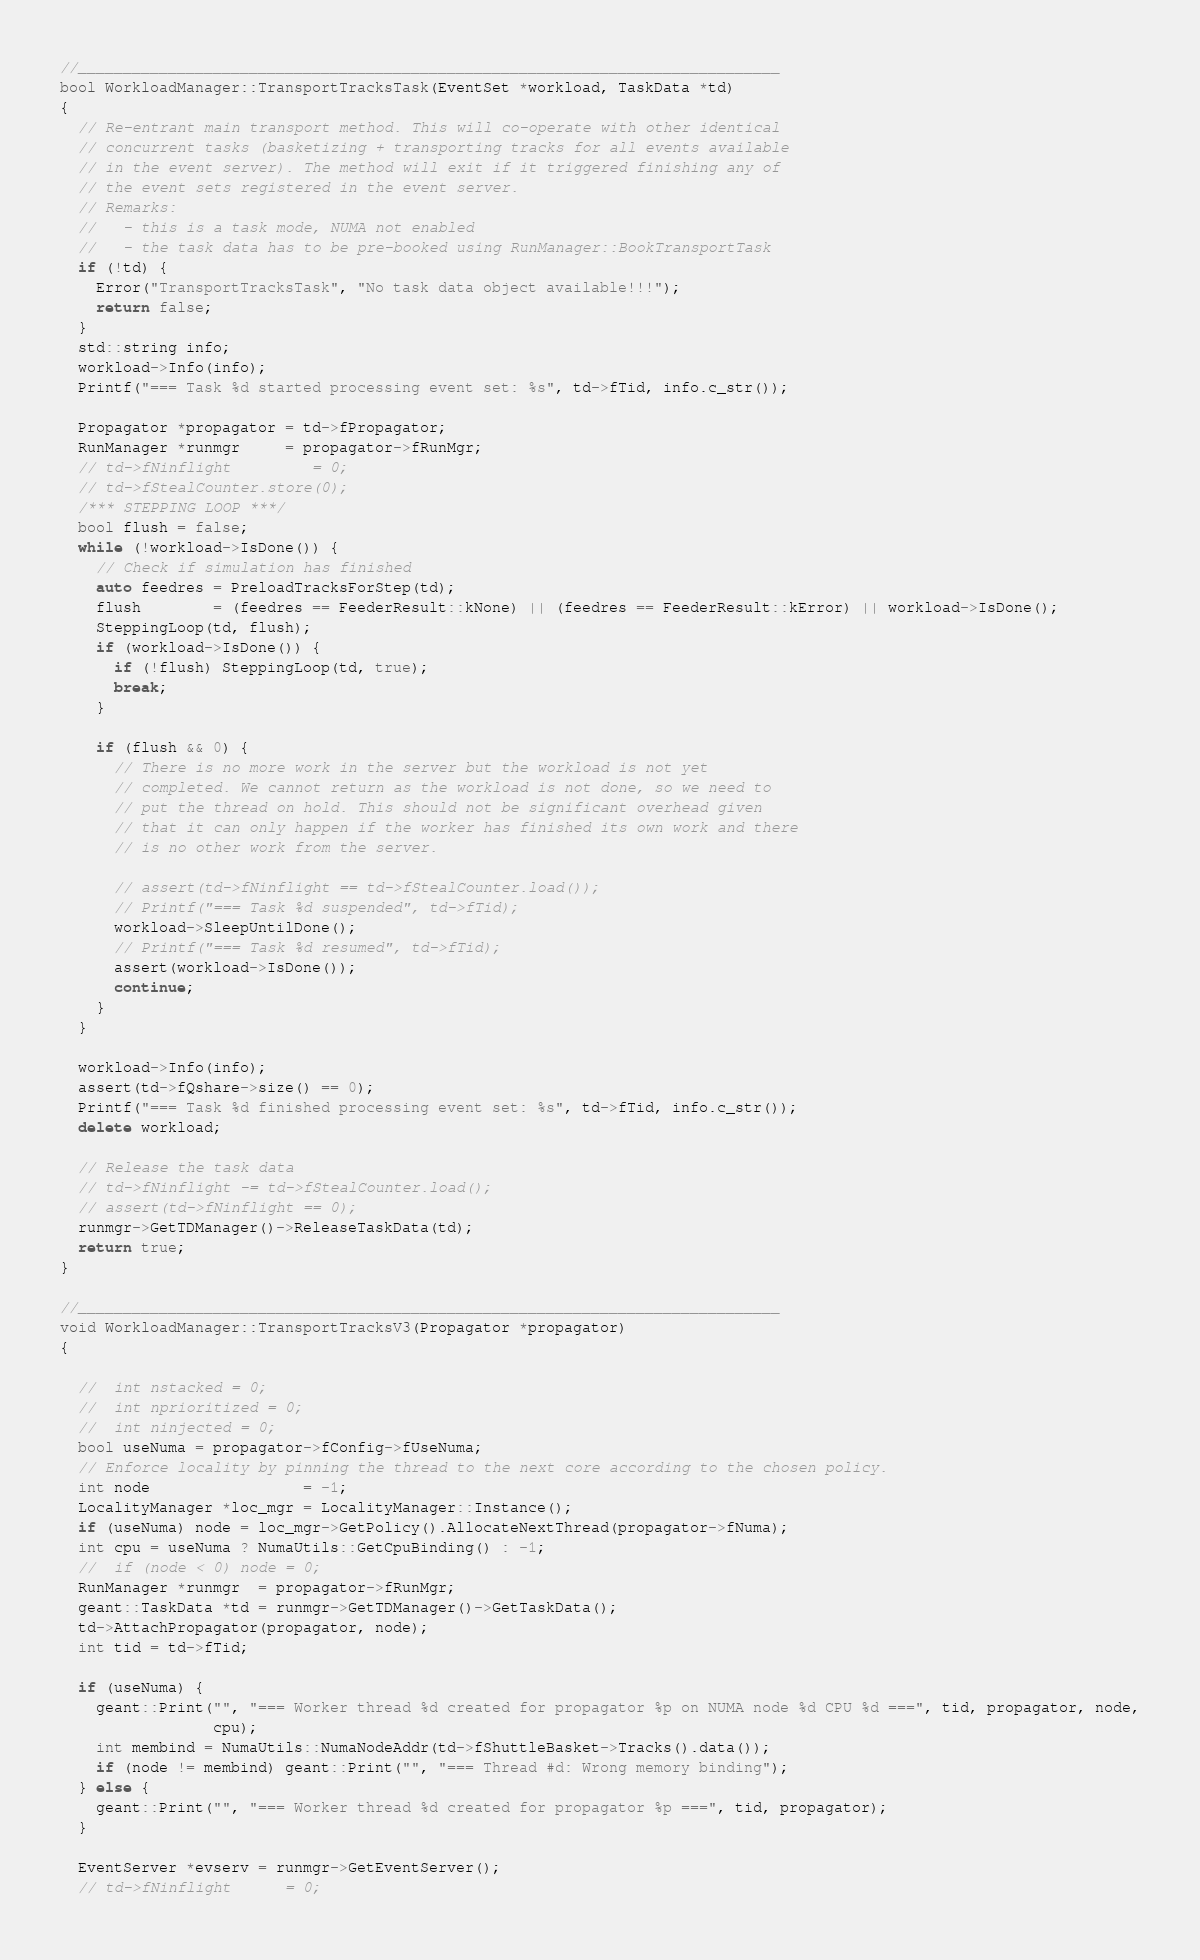Convert code to text. <code><loc_0><loc_0><loc_500><loc_500><_C++_>//______________________________________________________________________________
bool WorkloadManager::TransportTracksTask(EventSet *workload, TaskData *td)
{
  // Re-entrant main transport method. This will co-operate with other identical
  // concurrent tasks (basketizing + transporting tracks for all events available
  // in the event server). The method will exit if it triggered finishing any of
  // the event sets registered in the event server.
  // Remarks:
  //   - this is a task mode, NUMA not enabled
  //   - the task data has to be pre-booked using RunManager::BookTransportTask
  if (!td) {
    Error("TransportTracksTask", "No task data object available!!!");
    return false;
  }
  std::string info;
  workload->Info(info);
  Printf("=== Task %d started processing event set: %s", td->fTid, info.c_str());

  Propagator *propagator = td->fPropagator;
  RunManager *runmgr     = propagator->fRunMgr;
  // td->fNinflight         = 0;
  // td->fStealCounter.store(0);
  /*** STEPPING LOOP ***/
  bool flush = false;
  while (!workload->IsDone()) {
    // Check if simulation has finished
    auto feedres = PreloadTracksForStep(td);
    flush        = (feedres == FeederResult::kNone) || (feedres == FeederResult::kError) || workload->IsDone();
    SteppingLoop(td, flush);
    if (workload->IsDone()) {
      if (!flush) SteppingLoop(td, true);
      break;
    }

    if (flush && 0) {
      // There is no more work in the server but the workload is not yet
      // completed. We cannot return as the workload is not done, so we need to
      // put the thread on hold. This should not be significant overhead given
      // that it can only happen if the worker has finished its own work and there
      // is no other work from the server.

      // assert(td->fNinflight == td->fStealCounter.load());
      // Printf("=== Task %d suspended", td->fTid);
      workload->SleepUntilDone();
      // Printf("=== Task %d resumed", td->fTid);
      assert(workload->IsDone());
      continue;
    }
  }

  workload->Info(info);
  assert(td->fQshare->size() == 0);
  Printf("=== Task %d finished processing event set: %s", td->fTid, info.c_str());
  delete workload;

  // Release the task data
  // td->fNinflight -= td->fStealCounter.load();
  // assert(td->fNinflight == 0);
  runmgr->GetTDManager()->ReleaseTaskData(td);
  return true;
}

//______________________________________________________________________________
void WorkloadManager::TransportTracksV3(Propagator *propagator)
{

  //  int nstacked = 0;
  //  int nprioritized = 0;
  //  int ninjected = 0;
  bool useNuma = propagator->fConfig->fUseNuma;
  // Enforce locality by pinning the thread to the next core according to the chosen policy.
  int node                 = -1;
  LocalityManager *loc_mgr = LocalityManager::Instance();
  if (useNuma) node = loc_mgr->GetPolicy().AllocateNextThread(propagator->fNuma);
  int cpu = useNuma ? NumaUtils::GetCpuBinding() : -1;
  //  if (node < 0) node = 0;
  RunManager *runmgr  = propagator->fRunMgr;
  geant::TaskData *td = runmgr->GetTDManager()->GetTaskData();
  td->AttachPropagator(propagator, node);
  int tid = td->fTid;

  if (useNuma) {
    geant::Print("", "=== Worker thread %d created for propagator %p on NUMA node %d CPU %d ===", tid, propagator, node,
                 cpu);
    int membind = NumaUtils::NumaNodeAddr(td->fShuttleBasket->Tracks().data());
    if (node != membind) geant::Print("", "=== Thread #d: Wrong memory binding");
  } else {
    geant::Print("", "=== Worker thread %d created for propagator %p ===", tid, propagator);
  }

  EventServer *evserv = runmgr->GetEventServer();
  // td->fNinflight      = 0;</code> 